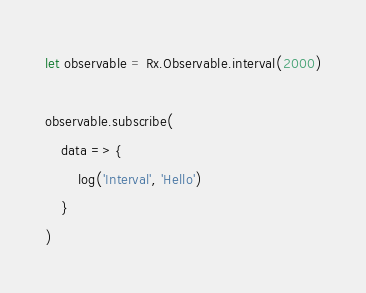Convert code to text. <code><loc_0><loc_0><loc_500><loc_500><_JavaScript_>let observable = Rx.Observable.interval(2000)

observable.subscribe(
    data => {
        log('Interval', 'Hello')
    }
)</code> 